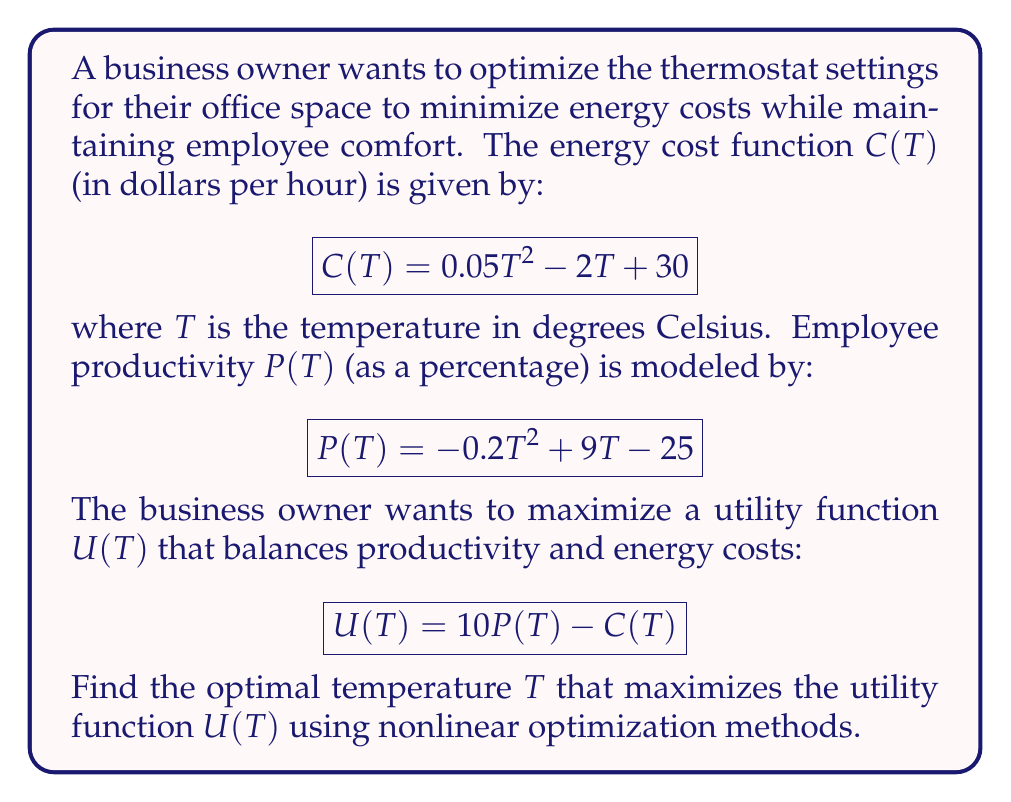Help me with this question. To find the optimal temperature, we need to maximize the utility function $U(T)$. We'll use calculus to find the maximum point.

Step 1: Express the utility function in terms of T.
$$U(T) = 10P(T) - C(T)$$
$$U(T) = 10(-0.2T^2 + 9T - 25) - (0.05T^2 - 2T + 30)$$
$$U(T) = -2T^2 + 90T - 250 - 0.05T^2 + 2T - 30$$
$$U(T) = -2.05T^2 + 92T - 280$$

Step 2: Find the first derivative of U(T).
$$U'(T) = -4.1T + 92$$

Step 3: Set the first derivative equal to zero and solve for T.
$$-4.1T + 92 = 0$$
$$-4.1T = -92$$
$$T = \frac{92}{4.1} \approx 22.44$$

Step 4: Verify that this is a maximum by checking the second derivative.
$$U''(T) = -4.1$$
Since $U''(T)$ is negative, the critical point is a maximum.

Step 5: Round the result to a practical thermostat setting.
The optimal temperature is approximately 22.4°C, which we can round to 22°C for practical purposes.
Answer: 22°C 